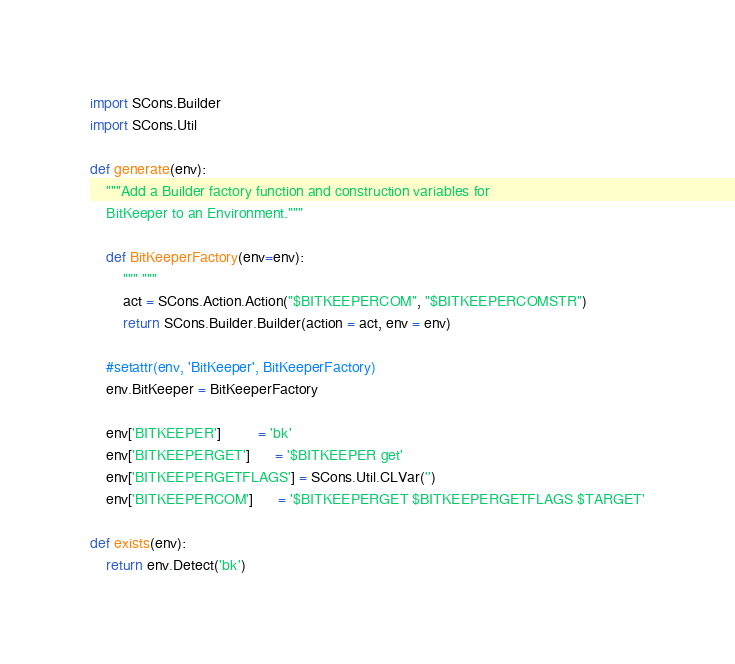Convert code to text. <code><loc_0><loc_0><loc_500><loc_500><_Python_>import SCons.Builder
import SCons.Util

def generate(env):
    """Add a Builder factory function and construction variables for
    BitKeeper to an Environment."""

    def BitKeeperFactory(env=env):
        """ """
        act = SCons.Action.Action("$BITKEEPERCOM", "$BITKEEPERCOMSTR")
        return SCons.Builder.Builder(action = act, env = env)

    #setattr(env, 'BitKeeper', BitKeeperFactory)
    env.BitKeeper = BitKeeperFactory

    env['BITKEEPER']         = 'bk'
    env['BITKEEPERGET']      = '$BITKEEPER get'
    env['BITKEEPERGETFLAGS'] = SCons.Util.CLVar('')
    env['BITKEEPERCOM']      = '$BITKEEPERGET $BITKEEPERGETFLAGS $TARGET'

def exists(env):
    return env.Detect('bk')
</code> 